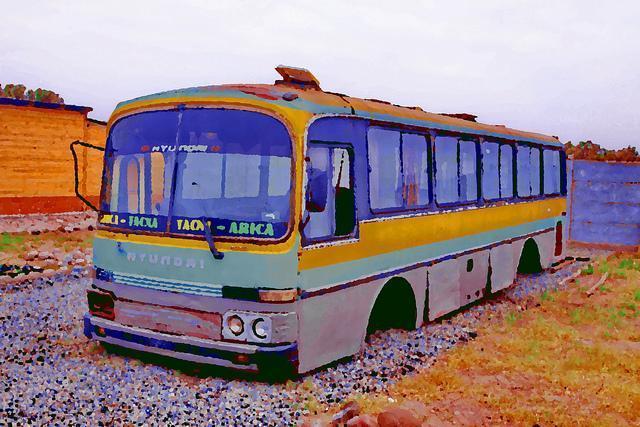How many people on the bus?
Give a very brief answer. 0. 